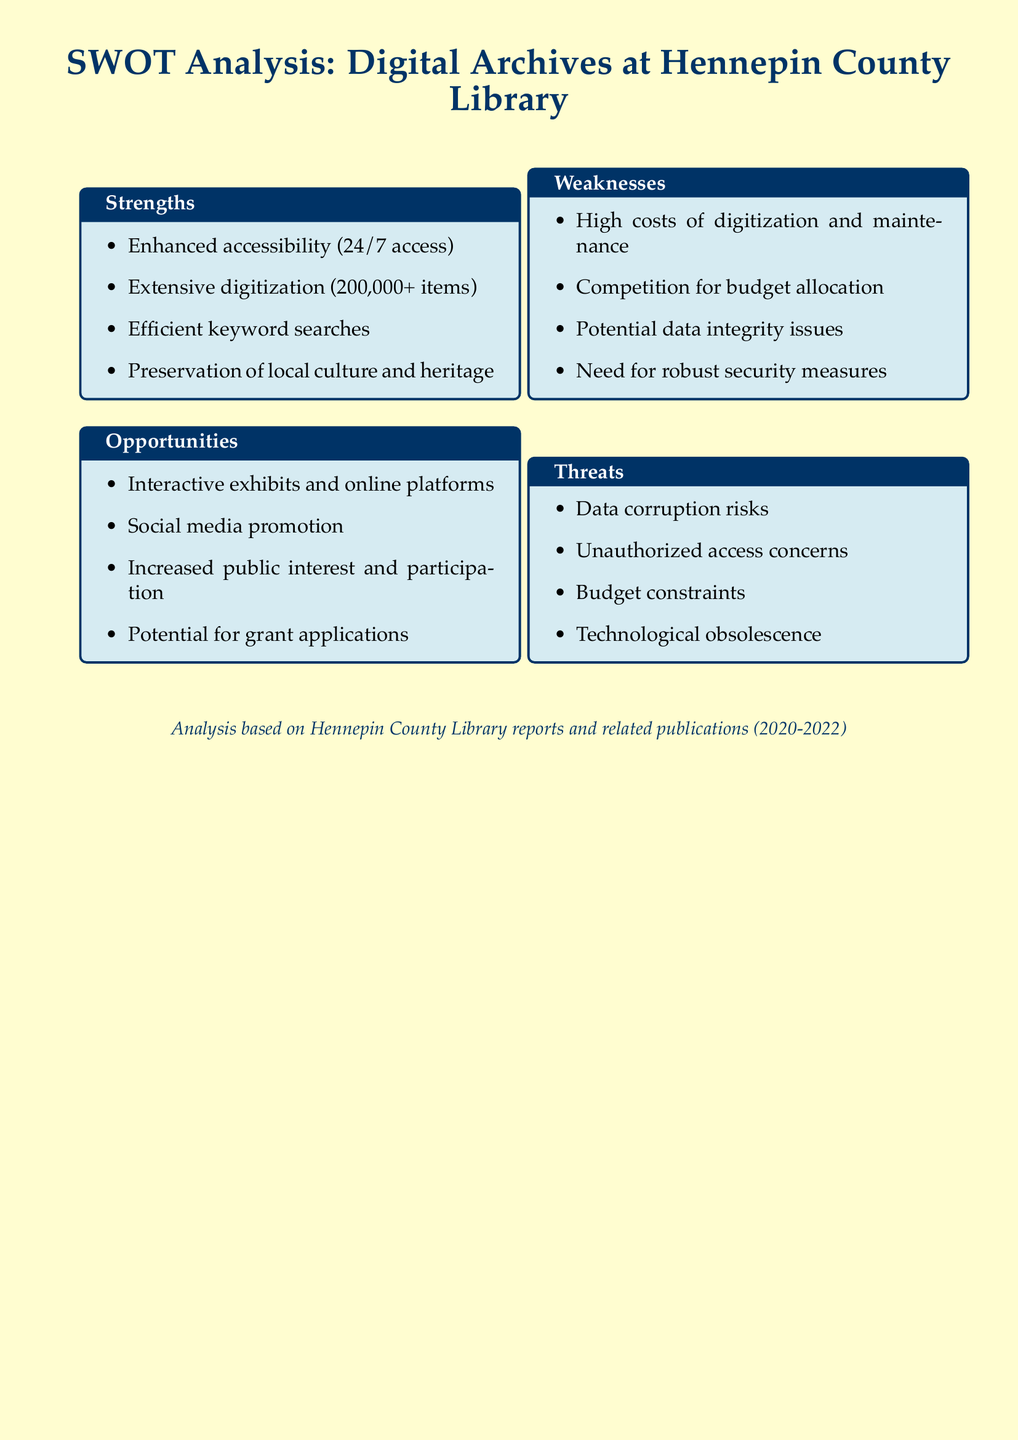what is the number of items digitized? The document states that over 200,000 items have been digitized at the Hennepin County Library.
Answer: 200,000+ what is a strength mentioned about digital archives? One of the strengths is the preservation of local culture and heritage, as noted in the document.
Answer: Preservation of local culture and heritage what is a weakness related to budget? The document mentions competition for budget allocation as a weakness.
Answer: Competition for budget allocation what opportunity involves social media? The document identifies social media promotion as an opportunity for digital archives.
Answer: Social media promotion what is the color of the document background? The document has a cream color for the background.
Answer: Cream what is one threat to digital archives mentioned? The document lists budget constraints as one of the threats facing digital archives.
Answer: Budget constraints which section includes risks like data corruption? The threat section of the SWOT analysis includes risks such as data corruption.
Answer: Threats what key feature allows efficient searching? Efficient keyword searches are emphasized as one of the strengths in the document.
Answer: Efficient keyword searches what is a major cost concern mentioned? The document highlights high costs of digitization and maintenance as a major concern.
Answer: High costs of digitization and maintenance 